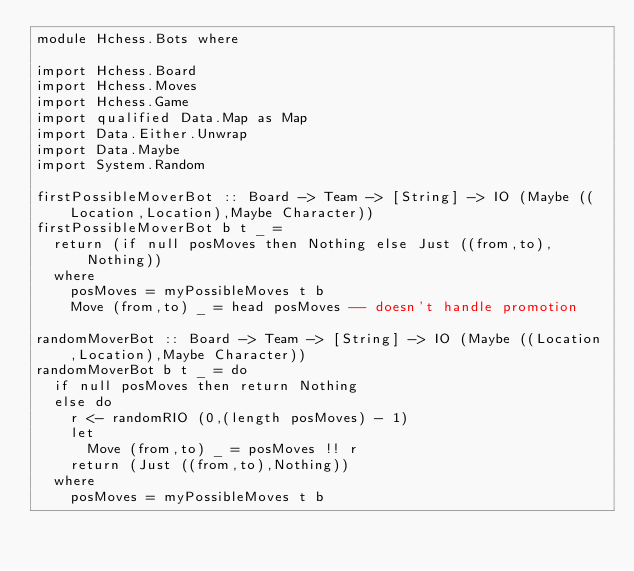Convert code to text. <code><loc_0><loc_0><loc_500><loc_500><_Haskell_>module Hchess.Bots where

import Hchess.Board
import Hchess.Moves
import Hchess.Game
import qualified Data.Map as Map
import Data.Either.Unwrap
import Data.Maybe
import System.Random

firstPossibleMoverBot :: Board -> Team -> [String] -> IO (Maybe ((Location,Location),Maybe Character))
firstPossibleMoverBot b t _ =
  return (if null posMoves then Nothing else Just ((from,to),Nothing))
  where
    posMoves = myPossibleMoves t b
    Move (from,to) _ = head posMoves -- doesn't handle promotion

randomMoverBot :: Board -> Team -> [String] -> IO (Maybe ((Location,Location),Maybe Character))
randomMoverBot b t _ = do
  if null posMoves then return Nothing
  else do
    r <- randomRIO (0,(length posMoves) - 1)
    let
      Move (from,to) _ = posMoves !! r
    return (Just ((from,to),Nothing))
  where
    posMoves = myPossibleMoves t b

</code> 